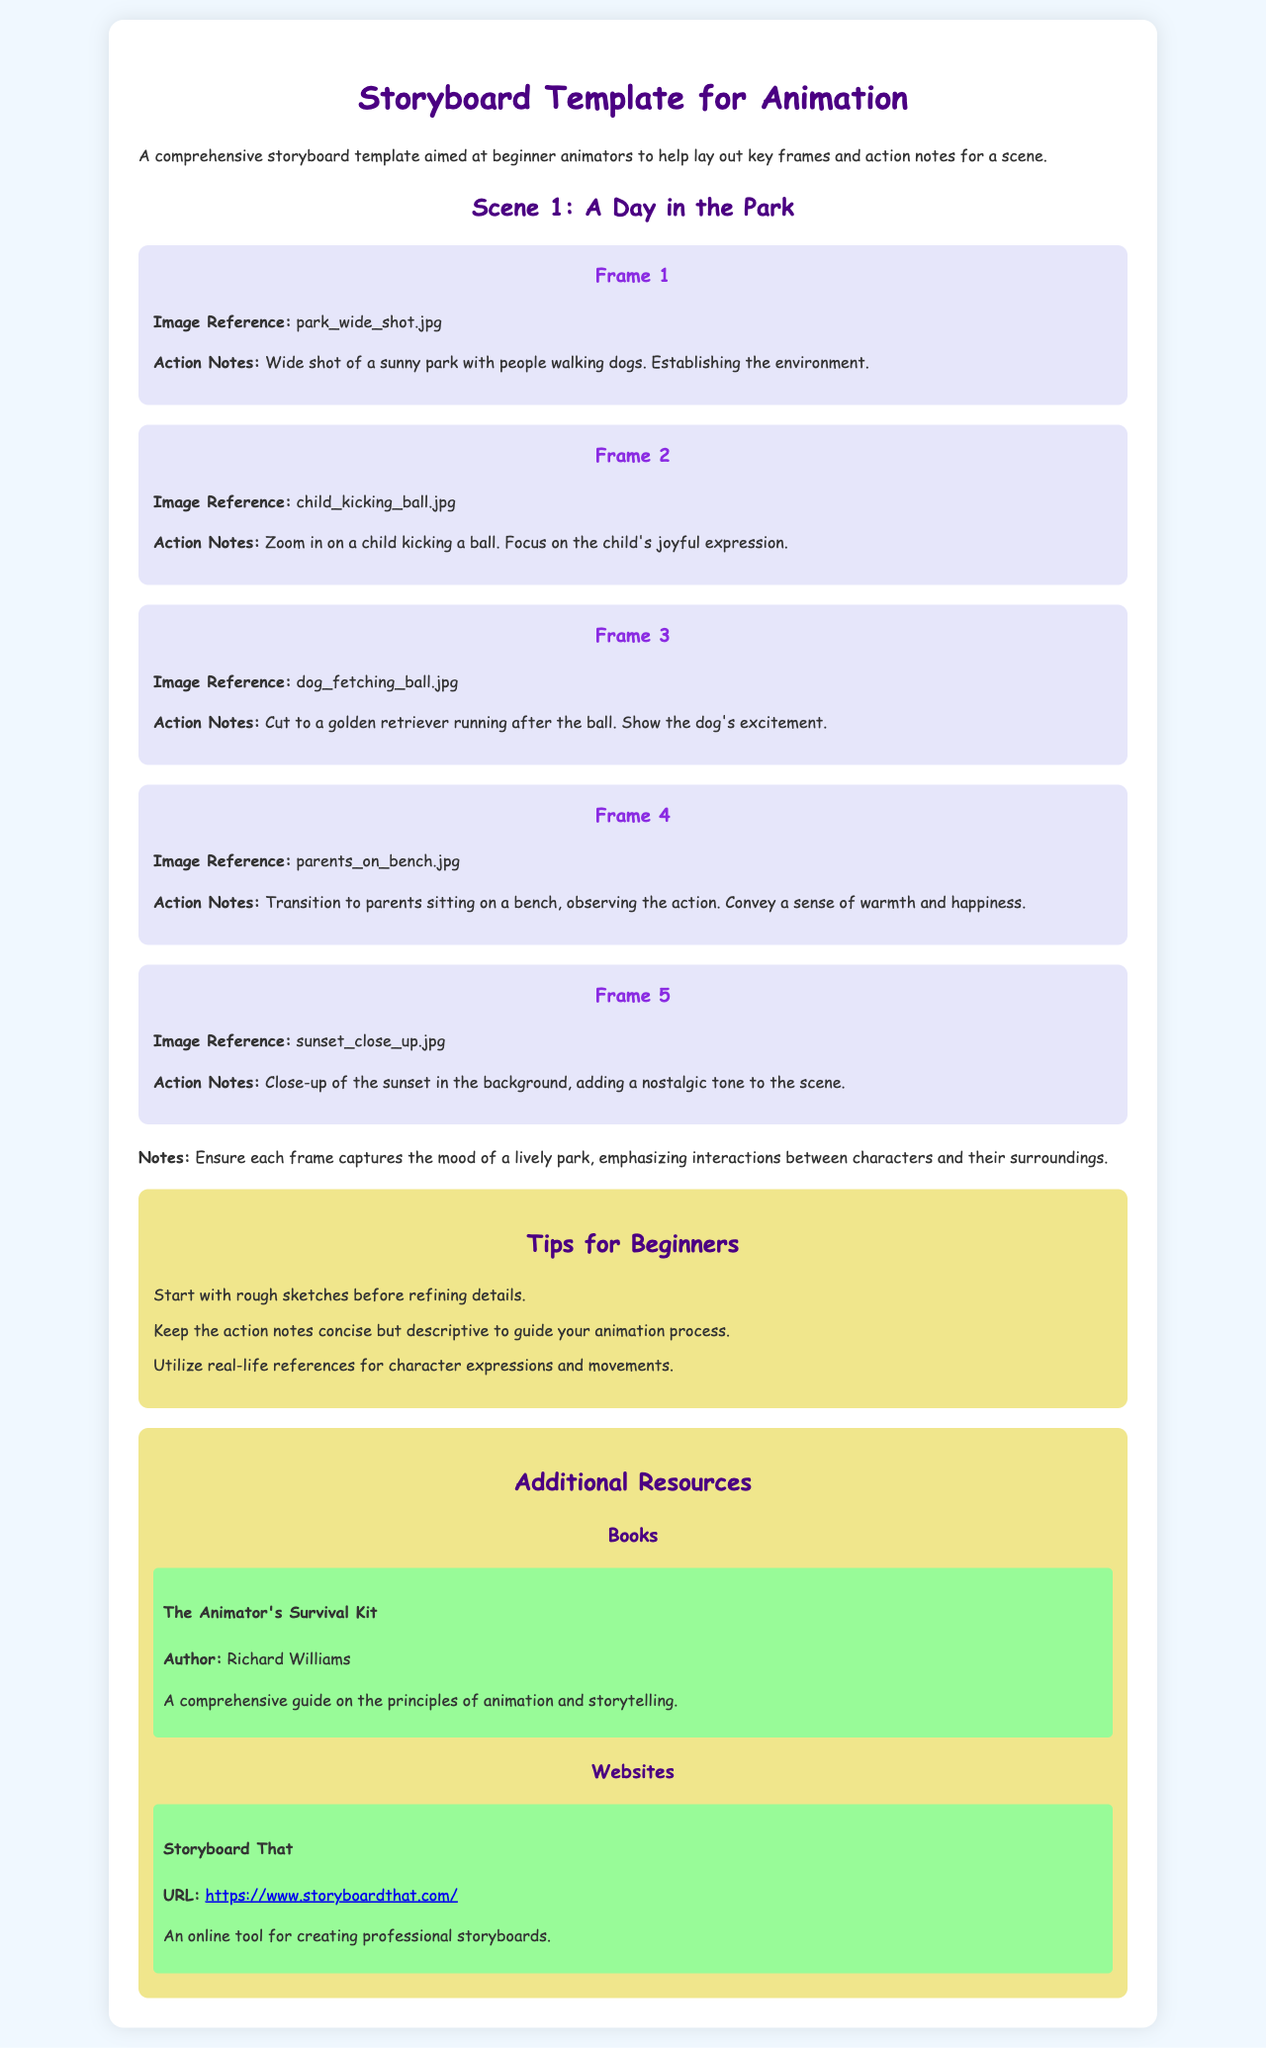What is the title of the document? The title is provided in the HTML document's <title> tag.
Answer: Storyboard Template for Animation How many frames are there in Scene 1? The number of frames is indicated by the sections titled "Frame" within the scene description.
Answer: 5 What is the image reference for Frame 3? The image reference is explicitly mentioned in the action notes for Frame 3.
Answer: dog_fetching_ball.jpg What type of shot is used in Frame 1? The type of shot is described in the action notes of Frame 1 which outlines the visual composition.
Answer: Wide shot What does the document suggest for beginners about sketches? Advice for beginners is provided in the tips section of the document.
Answer: Start with rough sketches What is the author of "The Animator's Survival Kit"? The author’s name is stated within the resources section, specifically under the book description.
Answer: Richard Williams What mood should each frame convey according to the notes? The mood expected from the frames is articulated in the notes following the frames section.
Answer: Lively park What tool is recommended for creating storyboards? The document lists a website in the resources section that serves this purpose.
Answer: Storyboard That 